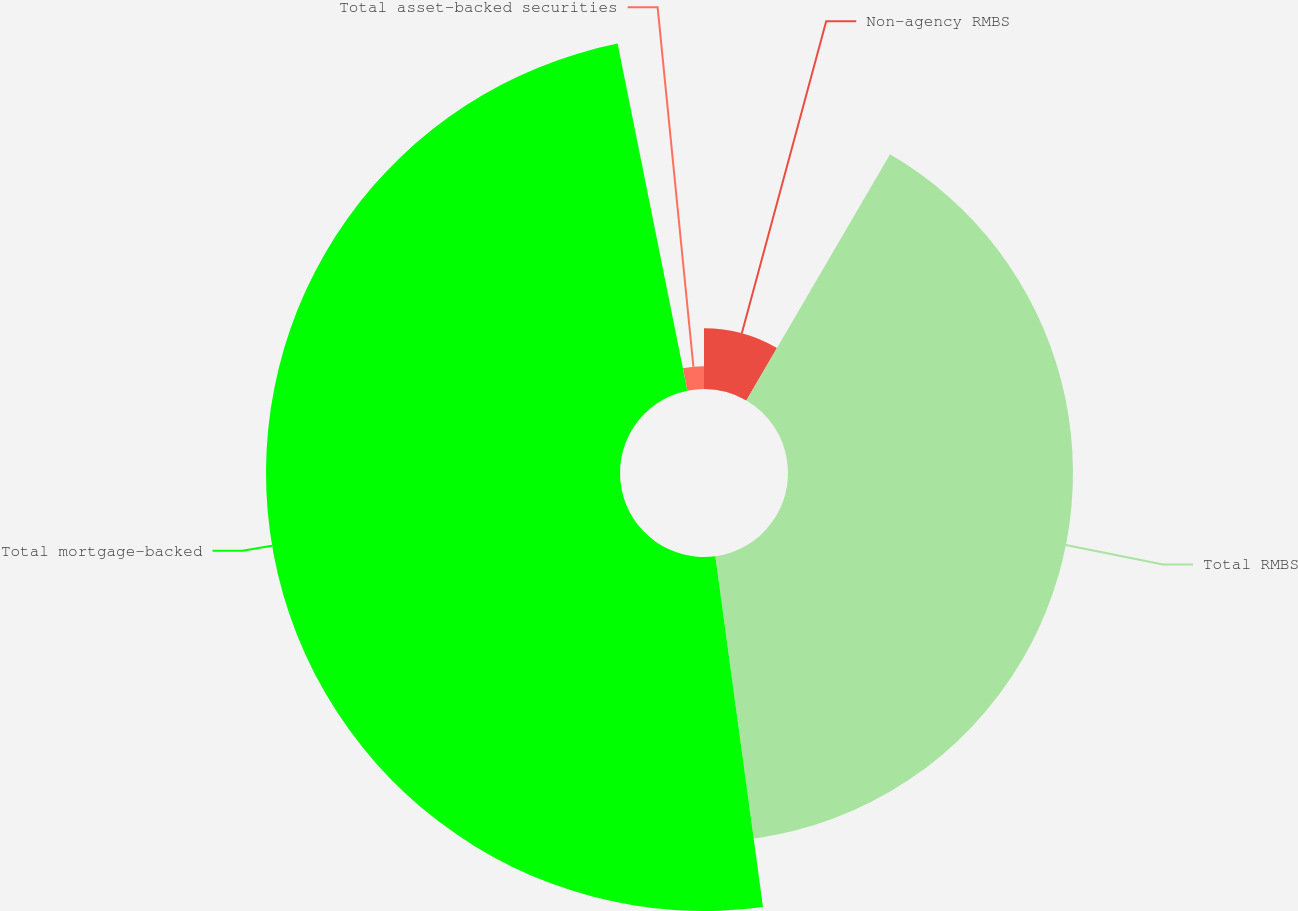Convert chart to OTSL. <chart><loc_0><loc_0><loc_500><loc_500><pie_chart><fcel>Non-agency RMBS<fcel>Total RMBS<fcel>Total mortgage-backed<fcel>Total asset-backed securities<nl><fcel>8.41%<fcel>39.44%<fcel>48.99%<fcel>3.16%<nl></chart> 